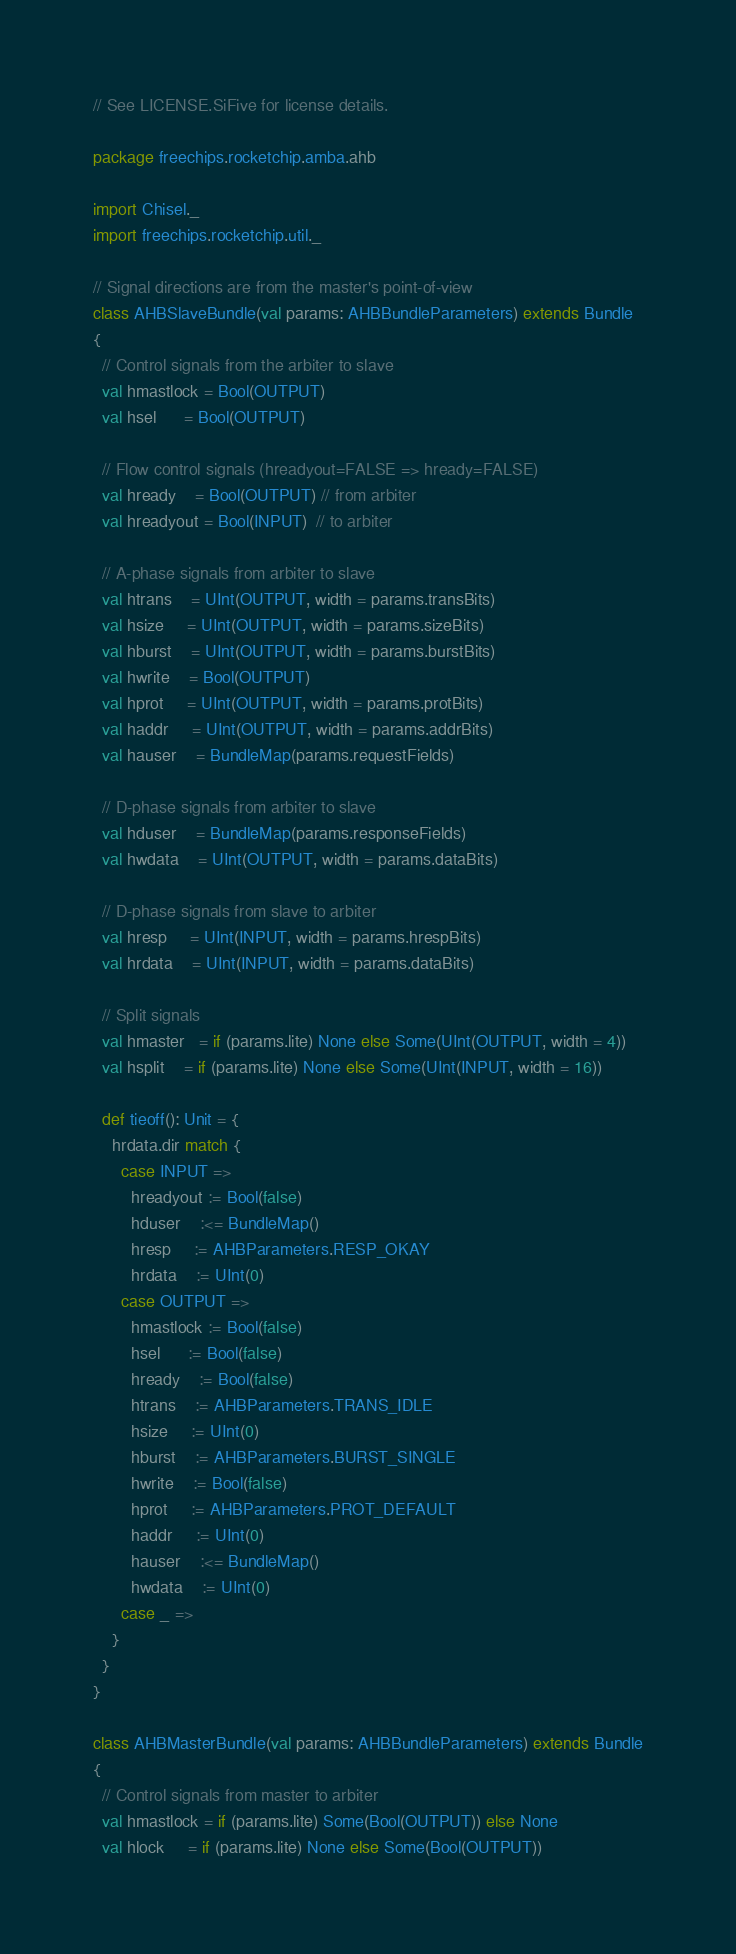<code> <loc_0><loc_0><loc_500><loc_500><_Scala_>// See LICENSE.SiFive for license details.

package freechips.rocketchip.amba.ahb

import Chisel._
import freechips.rocketchip.util._

// Signal directions are from the master's point-of-view
class AHBSlaveBundle(val params: AHBBundleParameters) extends Bundle
{
  // Control signals from the arbiter to slave
  val hmastlock = Bool(OUTPUT)
  val hsel      = Bool(OUTPUT)

  // Flow control signals (hreadyout=FALSE => hready=FALSE)
  val hready    = Bool(OUTPUT) // from arbiter
  val hreadyout = Bool(INPUT)  // to arbiter

  // A-phase signals from arbiter to slave
  val htrans    = UInt(OUTPUT, width = params.transBits)
  val hsize     = UInt(OUTPUT, width = params.sizeBits)
  val hburst    = UInt(OUTPUT, width = params.burstBits)
  val hwrite    = Bool(OUTPUT)
  val hprot     = UInt(OUTPUT, width = params.protBits)
  val haddr     = UInt(OUTPUT, width = params.addrBits)
  val hauser    = BundleMap(params.requestFields)

  // D-phase signals from arbiter to slave
  val hduser    = BundleMap(params.responseFields)
  val hwdata    = UInt(OUTPUT, width = params.dataBits)

  // D-phase signals from slave to arbiter
  val hresp     = UInt(INPUT, width = params.hrespBits)
  val hrdata    = UInt(INPUT, width = params.dataBits)

  // Split signals
  val hmaster   = if (params.lite) None else Some(UInt(OUTPUT, width = 4))
  val hsplit    = if (params.lite) None else Some(UInt(INPUT, width = 16))

  def tieoff(): Unit = {
    hrdata.dir match {
      case INPUT =>
        hreadyout := Bool(false)
        hduser    :<= BundleMap()
        hresp     := AHBParameters.RESP_OKAY
        hrdata    := UInt(0)
      case OUTPUT => 
        hmastlock := Bool(false)
        hsel      := Bool(false)
        hready    := Bool(false)
        htrans    := AHBParameters.TRANS_IDLE
        hsize     := UInt(0)
        hburst    := AHBParameters.BURST_SINGLE
        hwrite    := Bool(false)
        hprot     := AHBParameters.PROT_DEFAULT
        haddr     := UInt(0)
        hauser    :<= BundleMap()
        hwdata    := UInt(0)
      case _ =>
    }
  }
}

class AHBMasterBundle(val params: AHBBundleParameters) extends Bundle
{
  // Control signals from master to arbiter
  val hmastlock = if (params.lite) Some(Bool(OUTPUT)) else None
  val hlock     = if (params.lite) None else Some(Bool(OUTPUT))</code> 